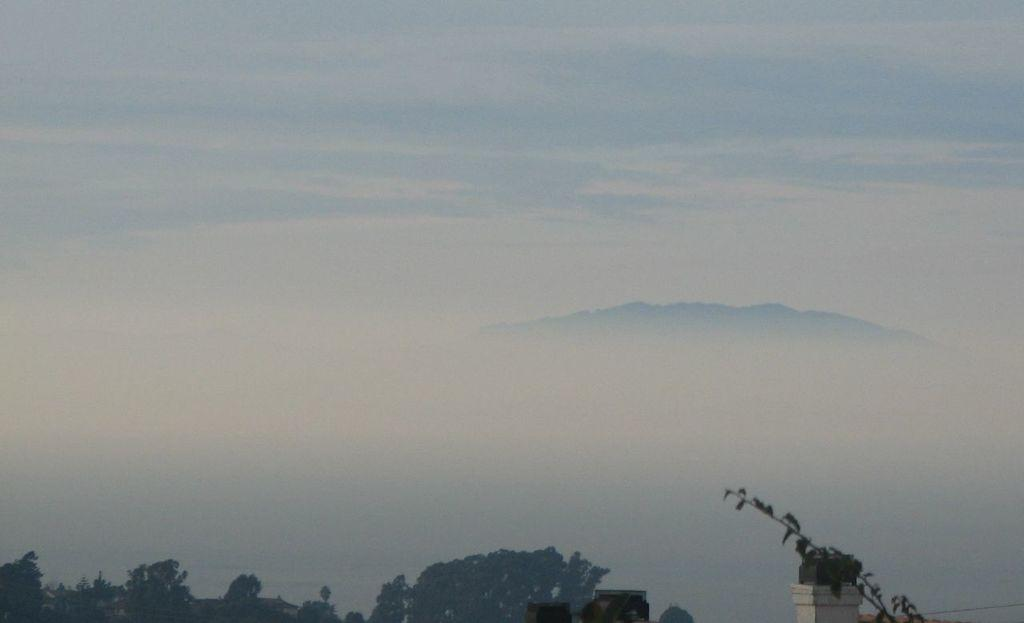What can be seen in the sky in the image? The sky with clouds is visible in the image. What type of vegetation is present at the bottom of the image? There are trees at the bottom of the image. Can you describe any other objects or features in the image? There are other unspecified objects in the image. What type of cat can be seen climbing the mailbox in the image? There is no cat or mailbox present in the image. 